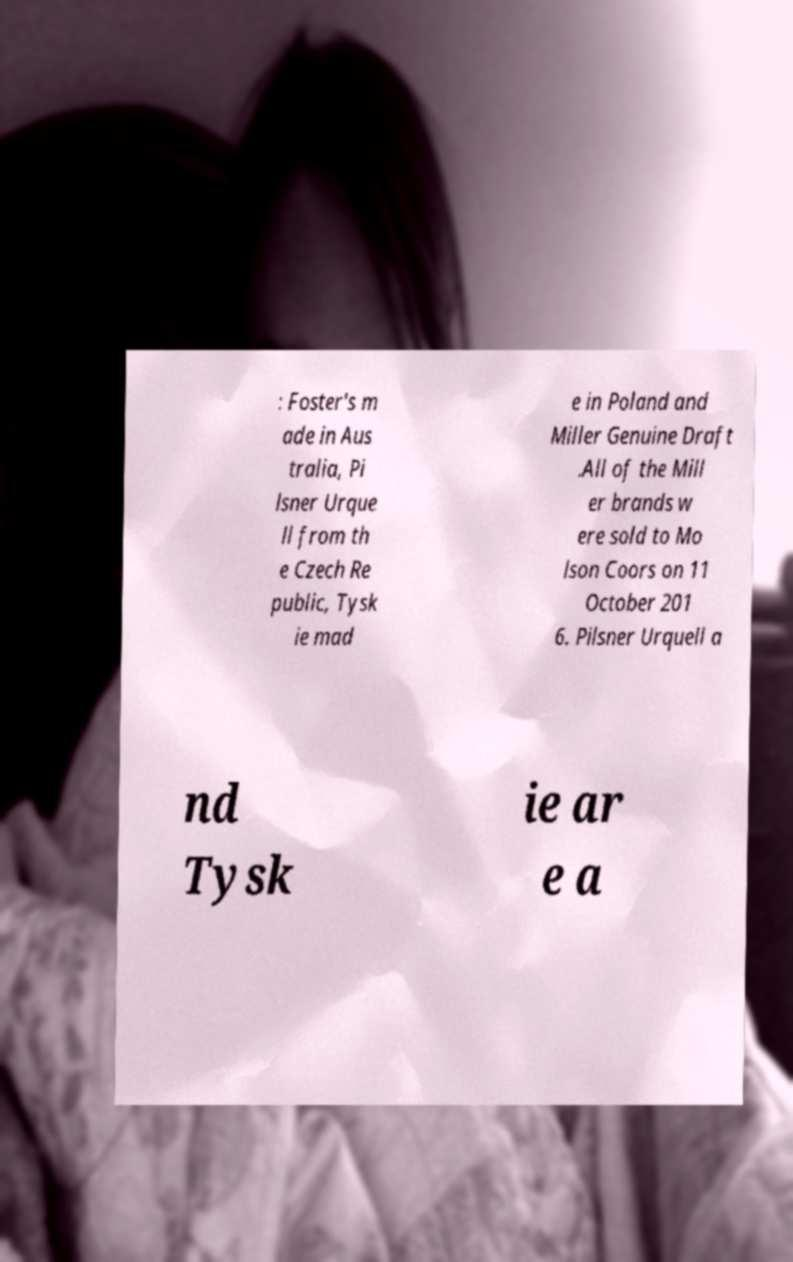Please read and relay the text visible in this image. What does it say? : Foster's m ade in Aus tralia, Pi lsner Urque ll from th e Czech Re public, Tysk ie mad e in Poland and Miller Genuine Draft .All of the Mill er brands w ere sold to Mo lson Coors on 11 October 201 6. Pilsner Urquell a nd Tysk ie ar e a 